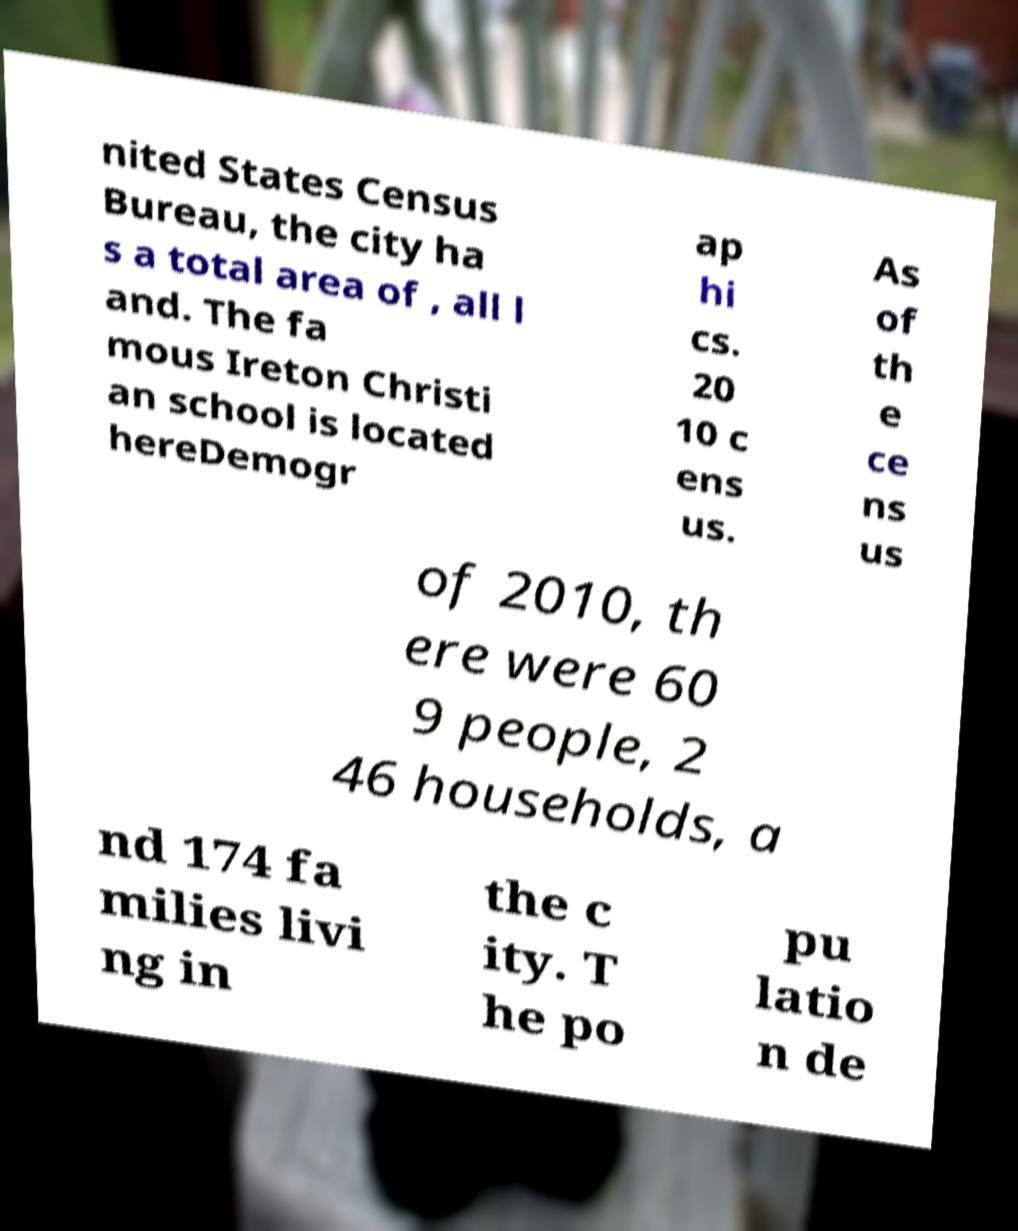Can you read and provide the text displayed in the image?This photo seems to have some interesting text. Can you extract and type it out for me? nited States Census Bureau, the city ha s a total area of , all l and. The fa mous Ireton Christi an school is located hereDemogr ap hi cs. 20 10 c ens us. As of th e ce ns us of 2010, th ere were 60 9 people, 2 46 households, a nd 174 fa milies livi ng in the c ity. T he po pu latio n de 